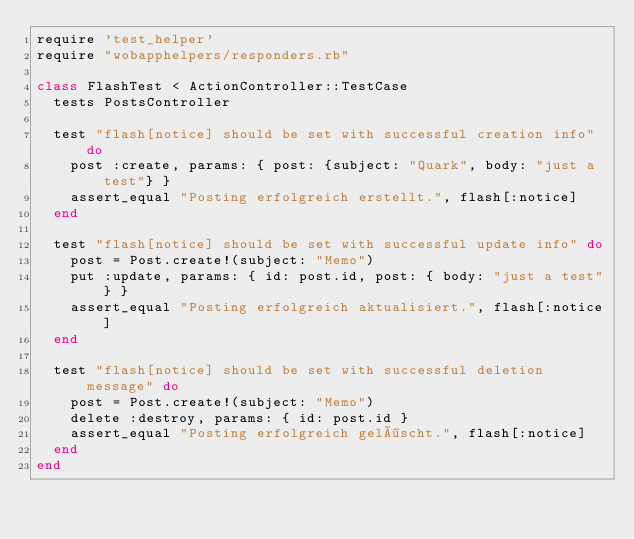Convert code to text. <code><loc_0><loc_0><loc_500><loc_500><_Ruby_>require 'test_helper'
require "wobapphelpers/responders.rb"

class FlashTest < ActionController::TestCase
  tests PostsController

  test "flash[notice] should be set with successful creation info" do
    post :create, params: { post: {subject: "Quark", body: "just a test"} }
    assert_equal "Posting erfolgreich erstellt.", flash[:notice]
  end

  test "flash[notice] should be set with successful update info" do
    post = Post.create!(subject: "Memo")
    put :update, params: { id: post.id, post: { body: "just a test"} }
    assert_equal "Posting erfolgreich aktualisiert.", flash[:notice]
  end

  test "flash[notice] should be set with successful deletion message" do
    post = Post.create!(subject: "Memo")
    delete :destroy, params: { id: post.id }
    assert_equal "Posting erfolgreich gelöscht.", flash[:notice]
  end
end
</code> 